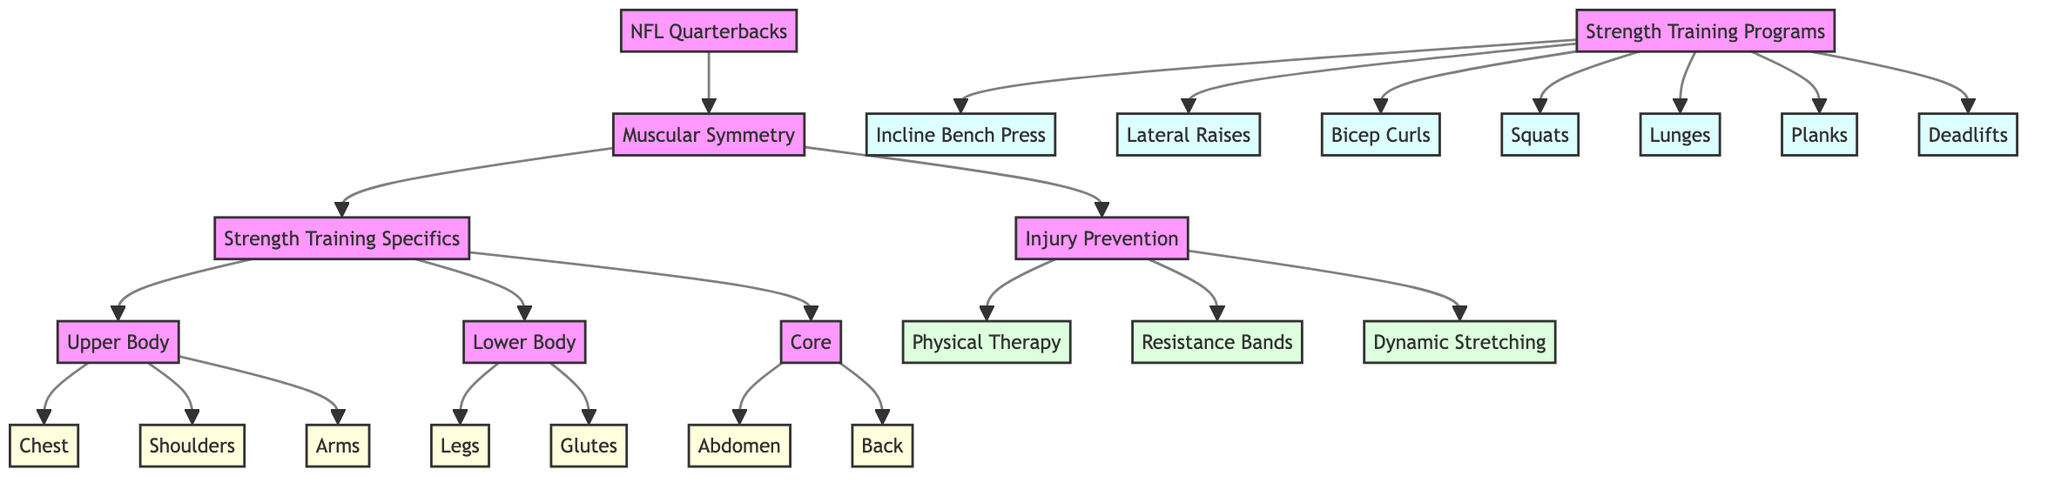What are the three main areas highlighted under "Strength Training Specifics"? The diagram shows that the three main areas of focus are Upper Body, Lower Body, and Core. These areas are directly connected to "Strength Training Specifics."
Answer: Upper Body, Lower Body, Core How many muscle groups are displayed in the diagram? The diagram includes seven muscle groups: Chest, Shoulders, Arms, Legs, Glutes, Abdomen, and Back. Each muscle group is connected to either the Upper Body or Lower Body sections, making a total of seven.
Answer: 7 What are the two exercises listed under "Upper Body"? The Upper Body section points to two exercises: Incline Bench Press and Lateral Raises. These exercises specifically target the muscles listed under Upper Body.
Answer: Incline Bench Press, Lateral Raises Which injury prevention methods are mentioned? The diagram lists three injury prevention methods: Physical Therapy, Resistance Bands, and Dynamic Stretching. These are linked to the "Injury Prevention" node and emphasize ways to reduce injury risk.
Answer: Physical Therapy, Resistance Bands, Dynamic Stretching What is the relationship between "Muscular Symmetry" and "Injury Prevention"? "Muscular Symmetry" is the central node linking both strength training specifics and injury prevention. The diagram indicates that achieving muscular symmetry helps inform injury prevention strategies for NFL quarterbacks.
Answer: Connection What strength training program focuses on the legs? The diagram specifies Squats and Lunges as the strength training exercises associated with the Lower Body. This indicates a tailored program focusing on strengthening leg muscles.
Answer: Squats, Lunges List one exercise for strengthening the core. The "Core" section indicates that Planks are the exercise designed to strengthen core muscles. Thus, it is a straightforward link between the core and its specific exercise.
Answer: Planks How many nodes are connected to the "Strength Training Programs"? The "Strength Training Programs" node is connected to seven different exercises: Incline Bench Press, Lateral Raises, Bicep Curls, Squats, Lunges, Planks, and Deadlifts. Hence, the total number of connected nodes is seven.
Answer: 7 